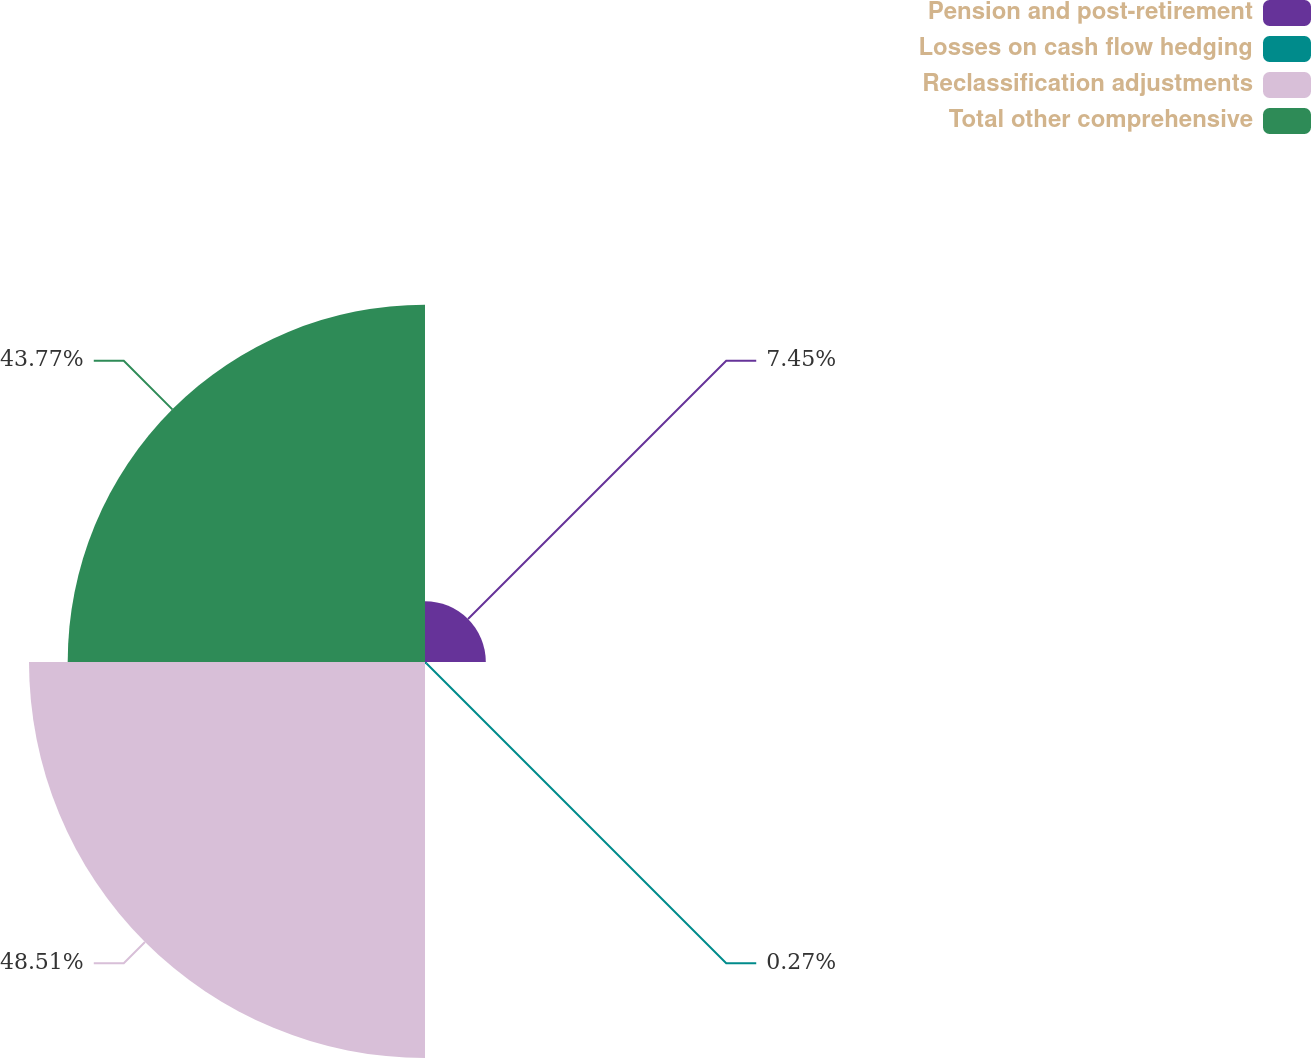<chart> <loc_0><loc_0><loc_500><loc_500><pie_chart><fcel>Pension and post-retirement<fcel>Losses on cash flow hedging<fcel>Reclassification adjustments<fcel>Total other comprehensive<nl><fcel>7.45%<fcel>0.27%<fcel>48.51%<fcel>43.77%<nl></chart> 